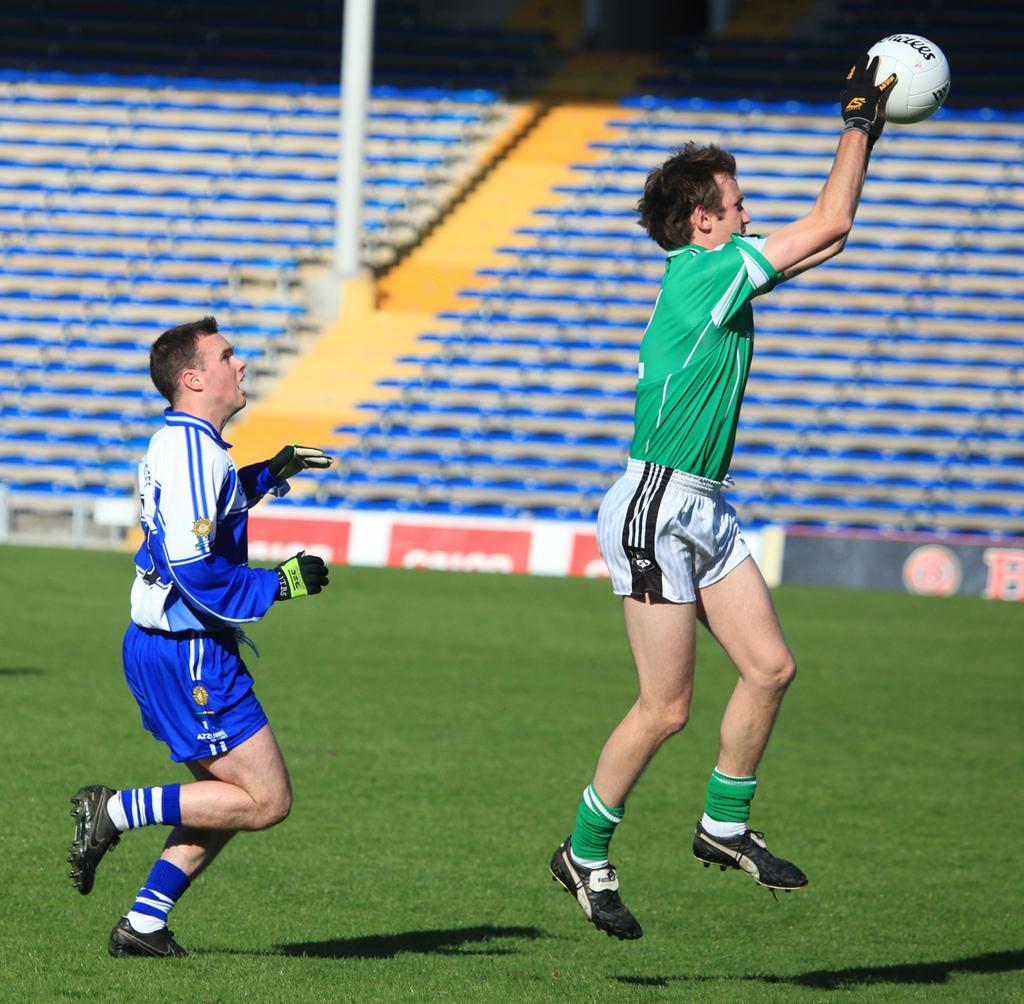How would you summarize this image in a sentence or two? In this image i can see two man playing a game at the background i can see few chairs and a pole. 